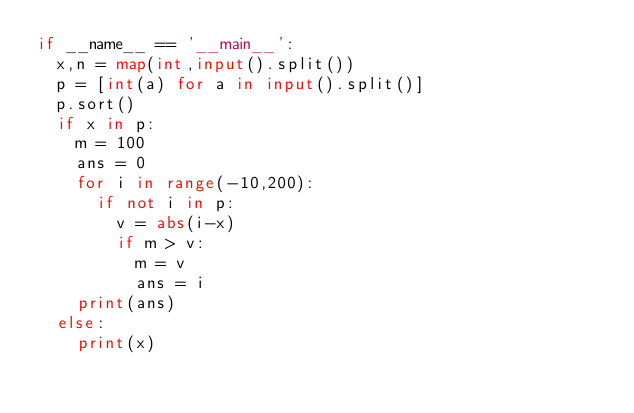Convert code to text. <code><loc_0><loc_0><loc_500><loc_500><_Python_>if __name__ == '__main__':
	x,n = map(int,input().split())
	p = [int(a) for a in input().split()]
	p.sort()
	if x in p:
		m = 100
		ans = 0
		for i in range(-10,200):
			if not i in p:
				v = abs(i-x)
				if m > v:
					m = v
					ans = i
		print(ans)
	else:
		print(x)</code> 